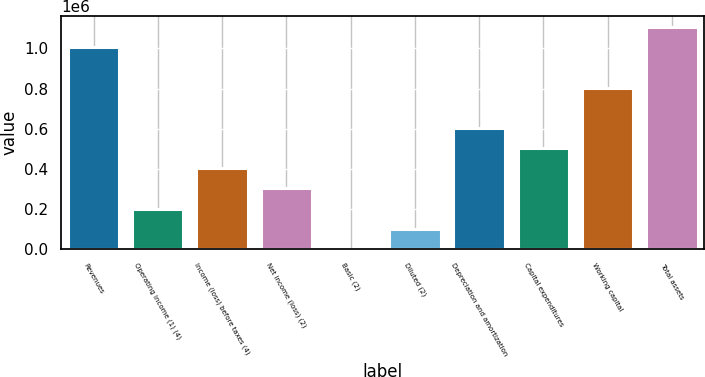Convert chart to OTSL. <chart><loc_0><loc_0><loc_500><loc_500><bar_chart><fcel>Revenues<fcel>Operating income (1) (4)<fcel>Income (loss) before taxes (4)<fcel>Net income (loss) (2)<fcel>Basic (2)<fcel>Diluted (2)<fcel>Depreciation and amortization<fcel>Capital expenditures<fcel>Working capital<fcel>Total assets<nl><fcel>1.00572e+06<fcel>201143<fcel>402286<fcel>301715<fcel>0.13<fcel>100572<fcel>603429<fcel>502858<fcel>804572<fcel>1.10629e+06<nl></chart> 